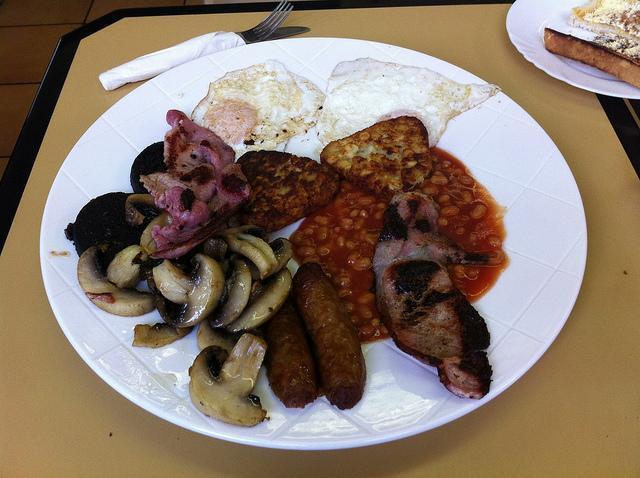How many eggs are served beside the hash browns in this breakfast plate?
Make your selection and explain in format: 'Answer: answer
Rationale: rationale.'
Options: Three, four, five, two. Answer: two.
Rationale: There are two eggs. 